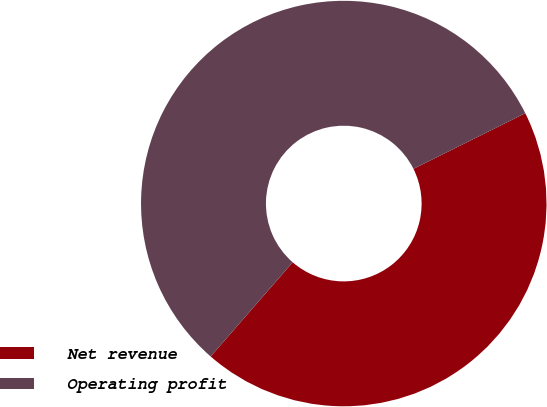Convert chart. <chart><loc_0><loc_0><loc_500><loc_500><pie_chart><fcel>Net revenue<fcel>Operating profit<nl><fcel>43.75%<fcel>56.25%<nl></chart> 